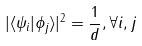<formula> <loc_0><loc_0><loc_500><loc_500>| \langle \psi _ { i } | \phi _ { j } \rangle | ^ { 2 } = \frac { 1 } { d } , \forall i , j</formula> 